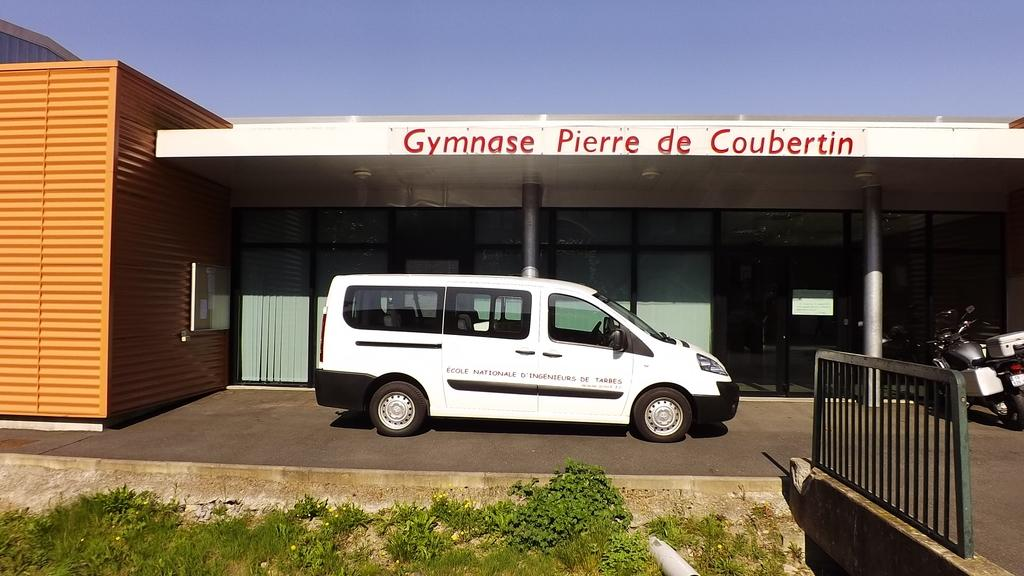<image>
Offer a succinct explanation of the picture presented. a Gymnase pierre sign that is above the van 